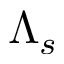<formula> <loc_0><loc_0><loc_500><loc_500>\Lambda _ { s }</formula> 